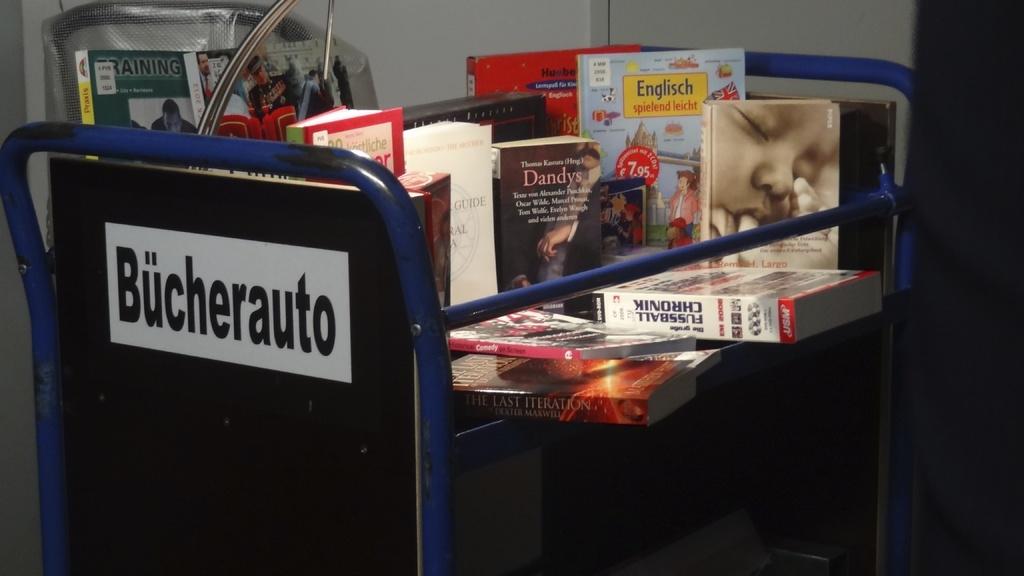Name one book on this table?
Make the answer very short. Dandys. 